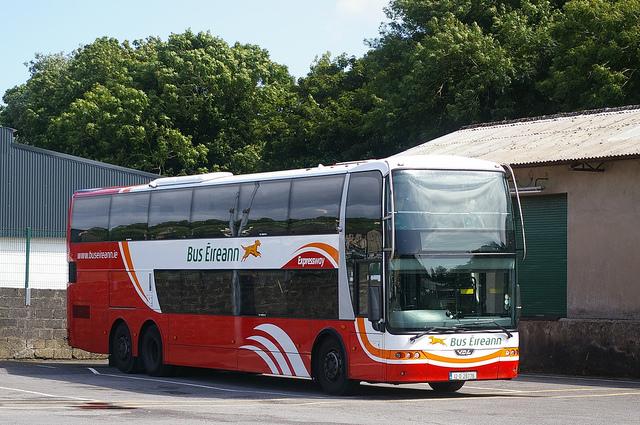What direction is this bus facing?
Short answer required. Right. Is there a driver?
Short answer required. No. What bus company is it?
Quick response, please. Bus eireann. 